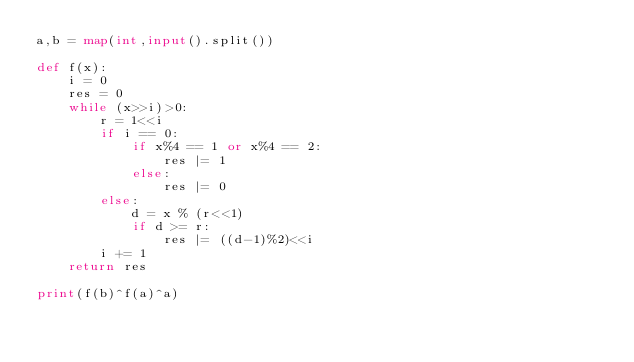Convert code to text. <code><loc_0><loc_0><loc_500><loc_500><_Python_>a,b = map(int,input().split())

def f(x):
    i = 0
    res = 0 
    while (x>>i)>0:
        r = 1<<i
        if i == 0:
            if x%4 == 1 or x%4 == 2:
                res |= 1
            else:
                res |= 0
        else:
            d = x % (r<<1)
            if d >= r:
                res |= ((d-1)%2)<<i
        i += 1      
    return res

print(f(b)^f(a)^a)

</code> 